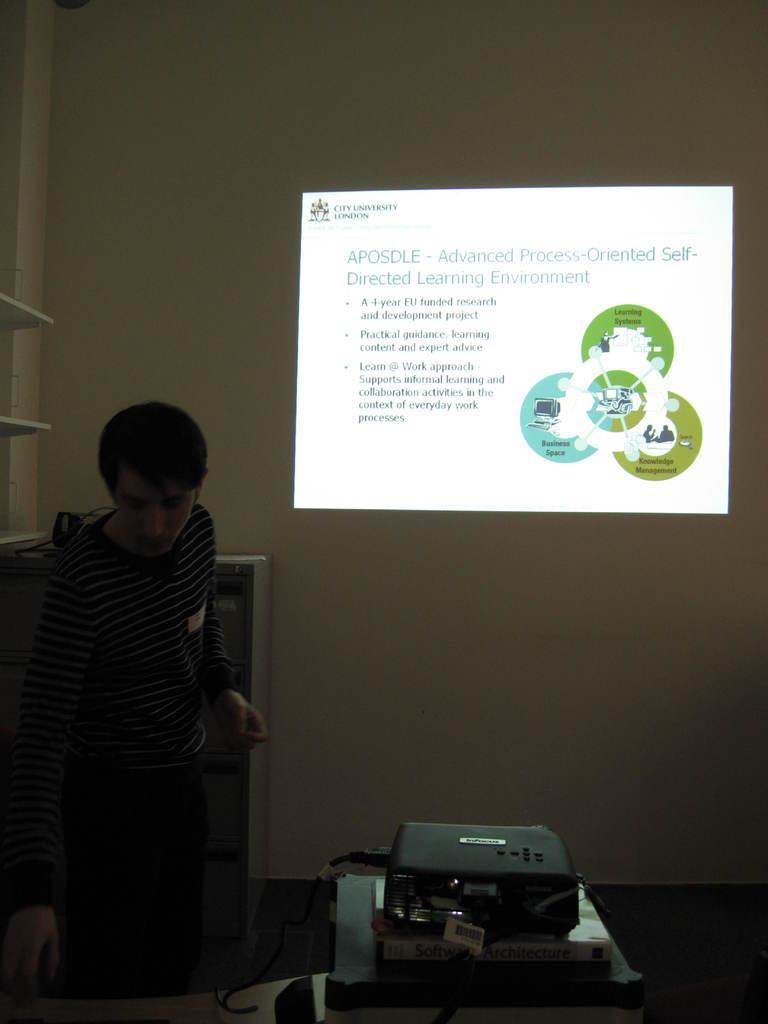Describe this image in one or two sentences. In this picture we can see a man standing on the floor, projector, bookshelves, screen on the wall and some objects. 